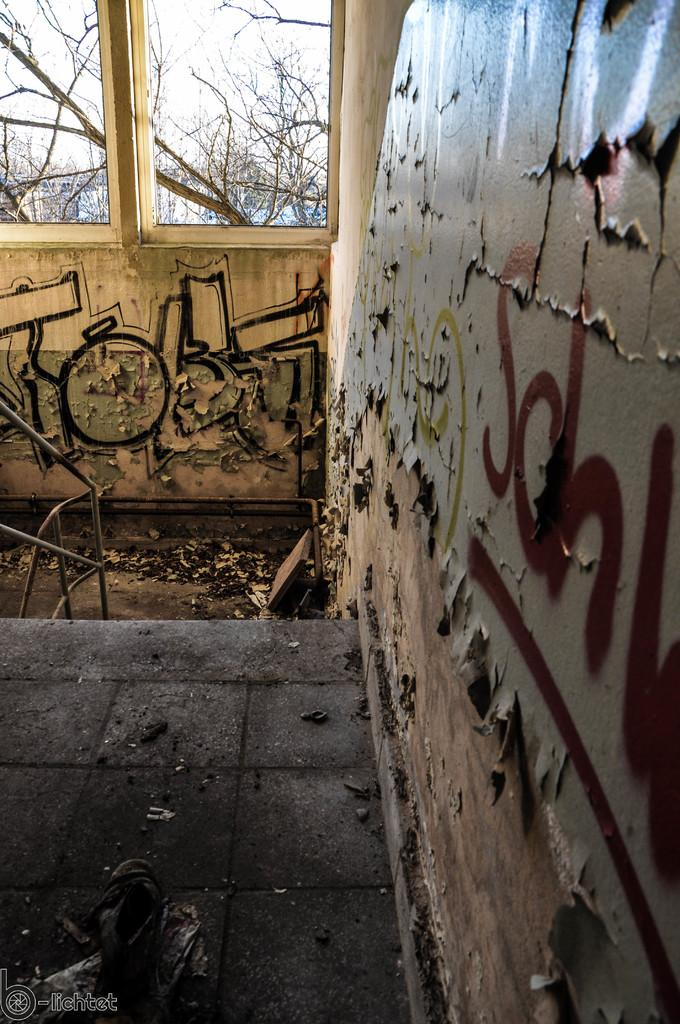What is present on the wall in the image? There are paintings on the wall in the image. How many windows can be seen in the background of the image? There are two windows in the background of the image. What can be seen through the windows? Trees are visible behind the windows. What type of stew is being cooked in the image? There is no stew present in the image; it features a wall with paintings and windows with trees visible behind them. Can you hear the bell ringing in the image? There is no bell present in the image, so it cannot be heard. 